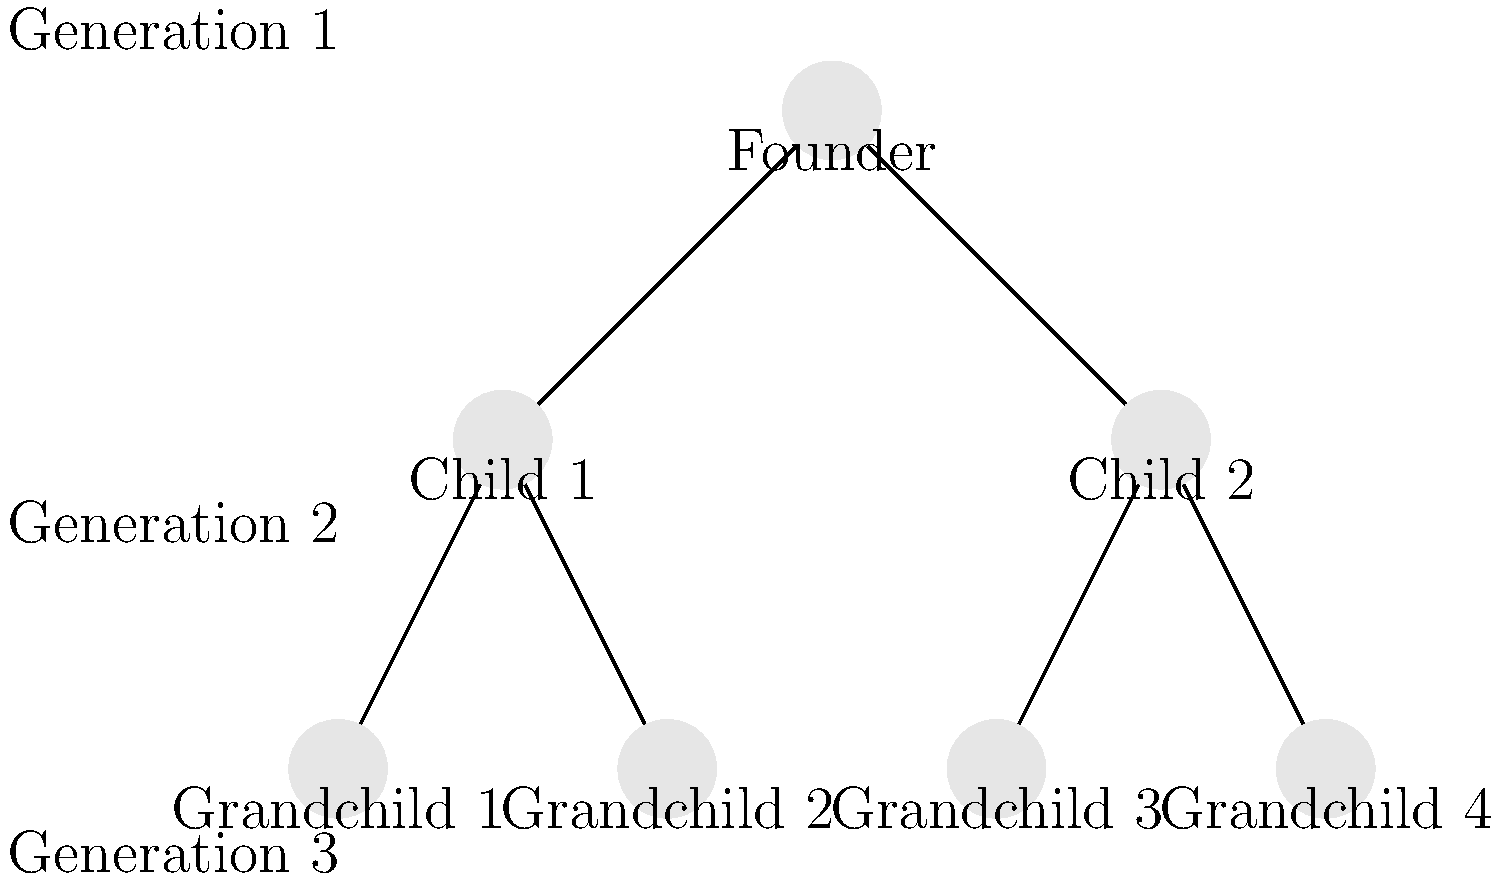In the family tree chart above, representing a family-owned business spanning three generations, what is the optimal number of successors to be groomed for leadership to ensure business continuity while minimizing potential conflicts? To determine the optimal number of successors for leadership in this family-owned business, we need to consider several factors:

1. Business continuity: Ensuring at least one capable successor is crucial.
2. Risk mitigation: Having multiple successors provides a backup plan.
3. Conflict prevention: Too many successors can lead to power struggles.
4. Generational representation: Including members from different generations can provide diverse perspectives.
5. Skill complementarity: Selecting successors with complementary skills can benefit the business.

Step-by-step analysis:
1. Generation 1 has the founder, who needs to plan for succession.
2. Generation 2 has two children, both potential successors.
3. Generation 3 has four grandchildren, providing a larger pool of potential successors.

Considering these factors:
- Choosing only one successor (e.g., Child 1 or Child 2) is risky and doesn't provide a backup.
- Selecting all six potential successors (two children and four grandchildren) would likely lead to conflicts and inefficient decision-making.
- A middle ground of 2-3 successors would be optimal:
  a) It provides a backup plan for business continuity.
  b) It allows for representation from both Generation 2 and Generation 3.
  c) It minimizes the potential for major conflicts while still allowing for diverse perspectives.
  d) It allows for the selection of individuals with complementary skills.

Therefore, the optimal number of successors to be groomed for leadership in this case is 2-3.
Answer: 2-3 successors 